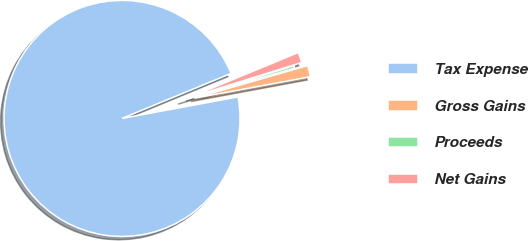Convert chart. <chart><loc_0><loc_0><loc_500><loc_500><pie_chart><fcel>Tax Expense<fcel>Gross Gains<fcel>Proceeds<fcel>Net Gains<nl><fcel>96.68%<fcel>1.55%<fcel>0.35%<fcel>1.42%<nl></chart> 